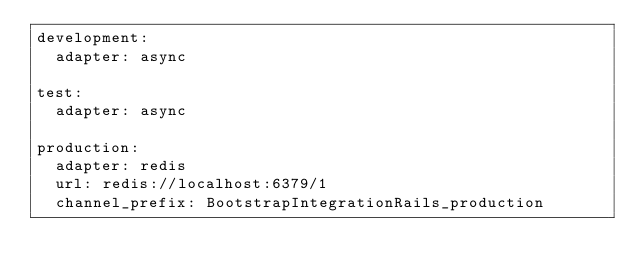Convert code to text. <code><loc_0><loc_0><loc_500><loc_500><_YAML_>development:
  adapter: async

test:
  adapter: async

production:
  adapter: redis
  url: redis://localhost:6379/1
  channel_prefix: BootstrapIntegrationRails_production
</code> 